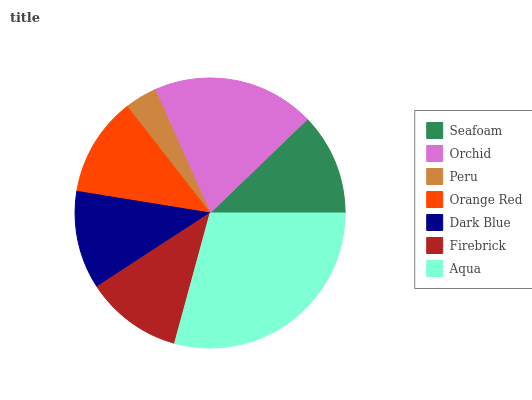Is Peru the minimum?
Answer yes or no. Yes. Is Aqua the maximum?
Answer yes or no. Yes. Is Orchid the minimum?
Answer yes or no. No. Is Orchid the maximum?
Answer yes or no. No. Is Orchid greater than Seafoam?
Answer yes or no. Yes. Is Seafoam less than Orchid?
Answer yes or no. Yes. Is Seafoam greater than Orchid?
Answer yes or no. No. Is Orchid less than Seafoam?
Answer yes or no. No. Is Orange Red the high median?
Answer yes or no. Yes. Is Orange Red the low median?
Answer yes or no. Yes. Is Aqua the high median?
Answer yes or no. No. Is Orchid the low median?
Answer yes or no. No. 